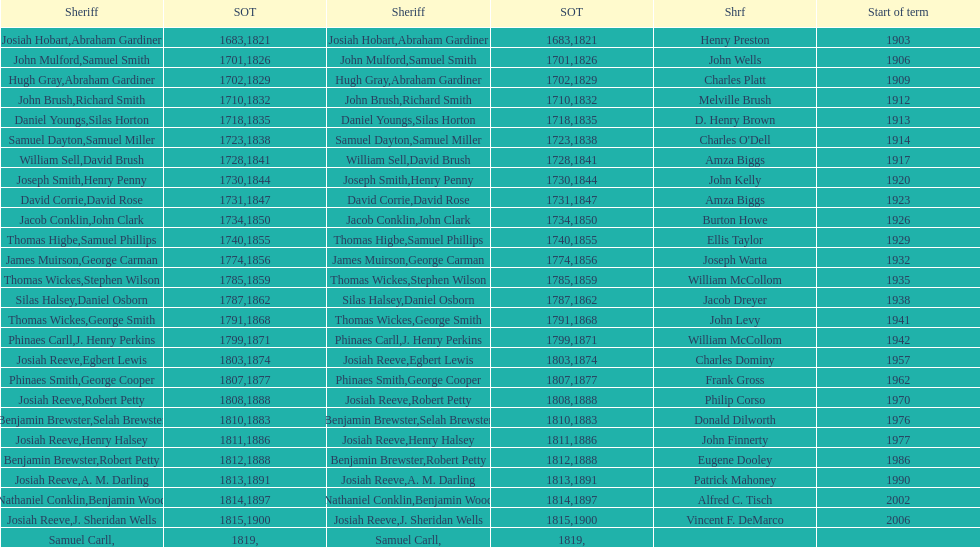What is the number of sheriff's with the last name smith? 5. 